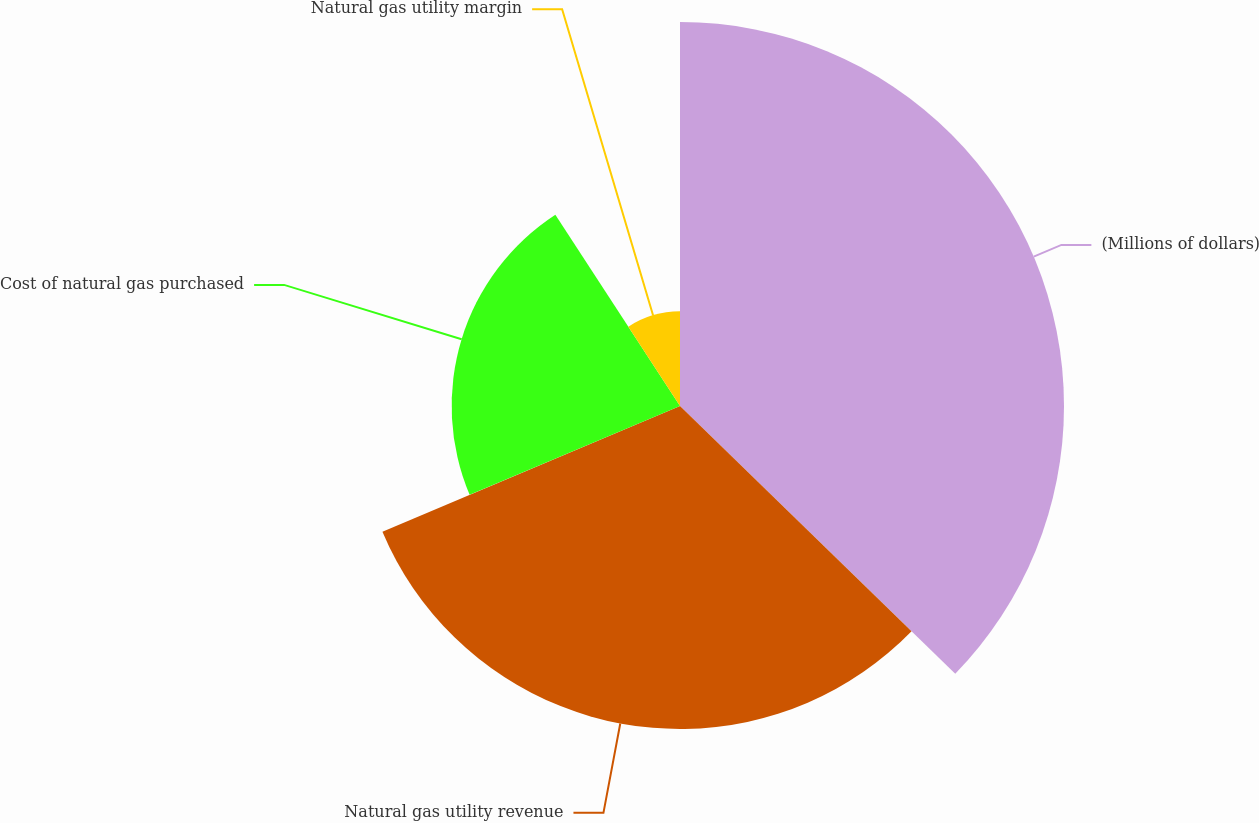<chart> <loc_0><loc_0><loc_500><loc_500><pie_chart><fcel>(Millions of dollars)<fcel>Natural gas utility revenue<fcel>Cost of natural gas purchased<fcel>Natural gas utility margin<nl><fcel>37.28%<fcel>31.36%<fcel>22.17%<fcel>9.19%<nl></chart> 